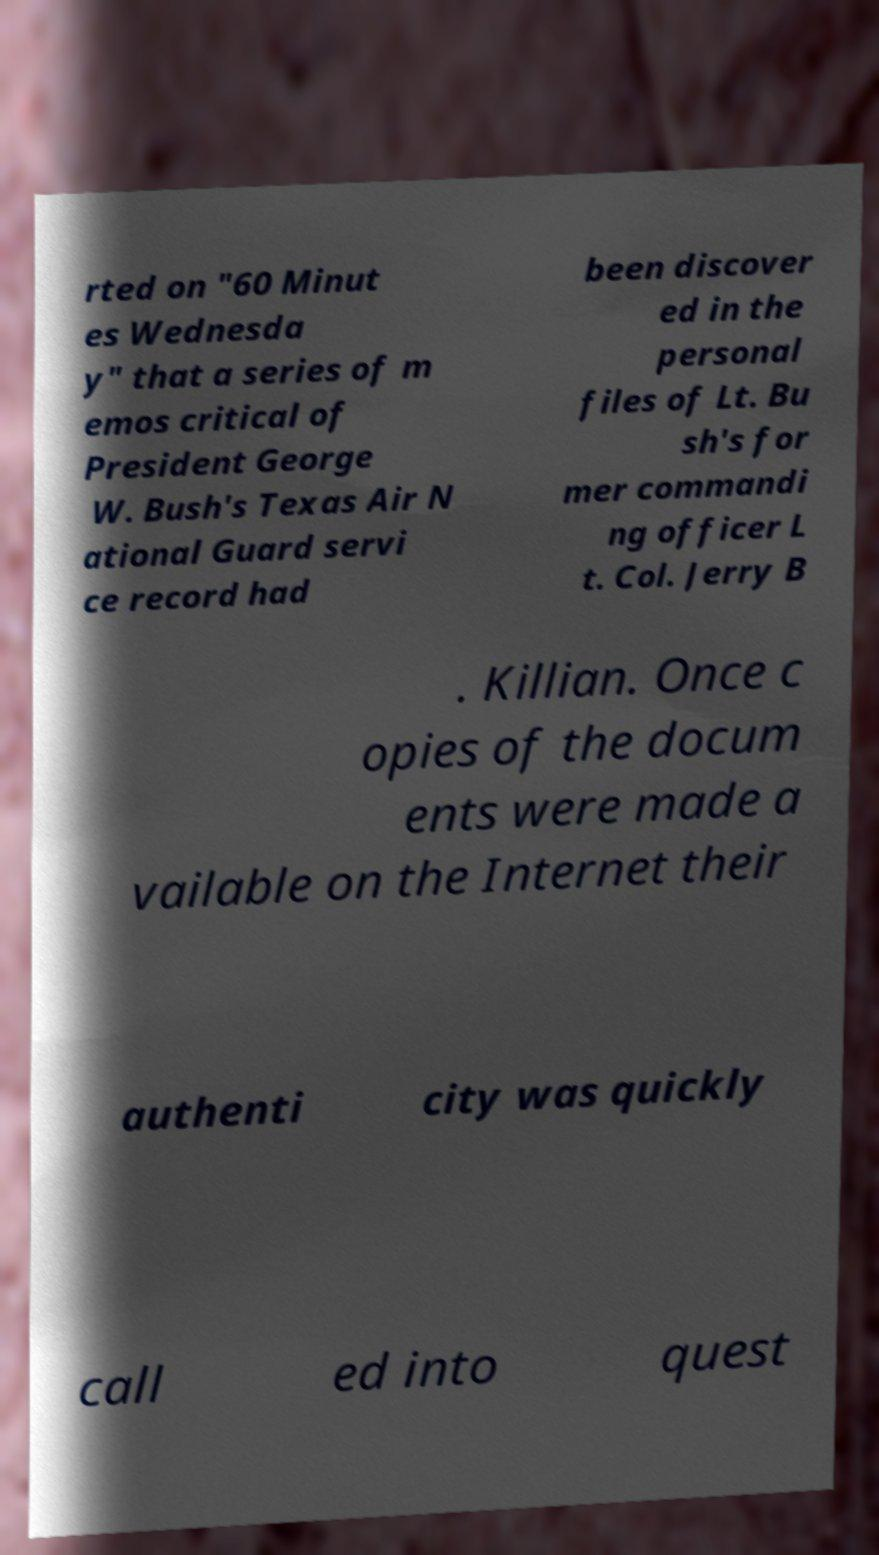What messages or text are displayed in this image? I need them in a readable, typed format. rted on "60 Minut es Wednesda y" that a series of m emos critical of President George W. Bush's Texas Air N ational Guard servi ce record had been discover ed in the personal files of Lt. Bu sh's for mer commandi ng officer L t. Col. Jerry B . Killian. Once c opies of the docum ents were made a vailable on the Internet their authenti city was quickly call ed into quest 